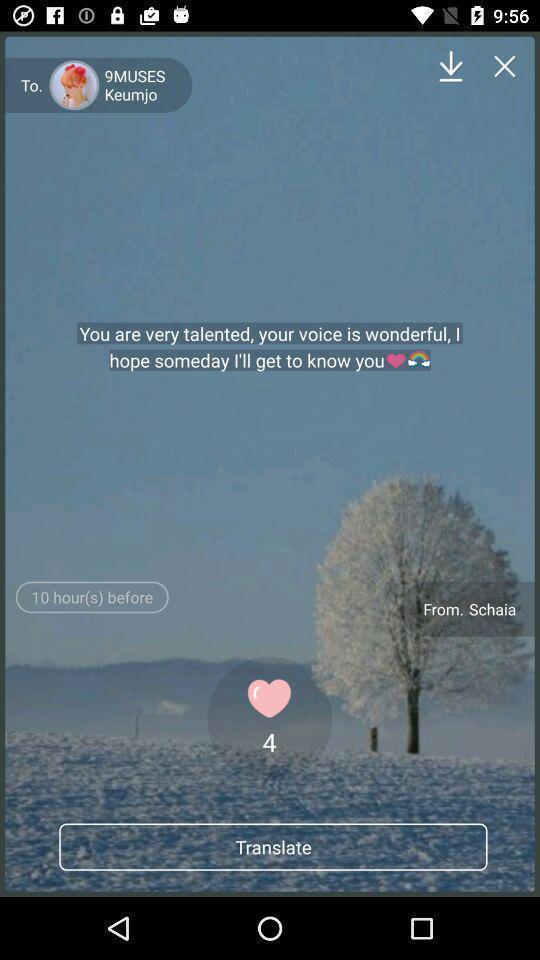What details can you identify in this image? Text in chat to translate in to your needed language. 